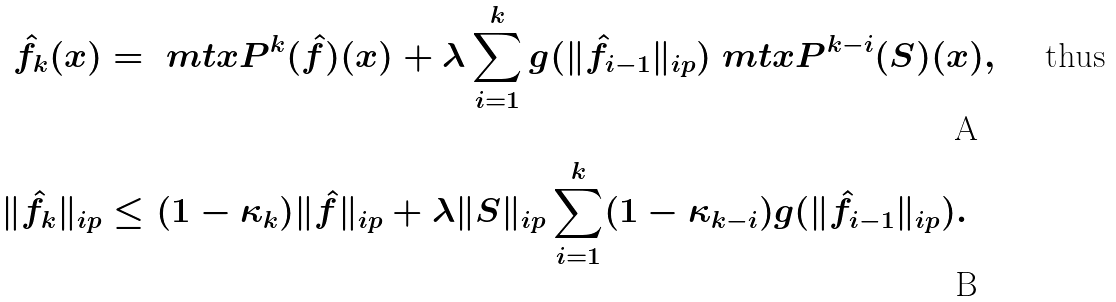Convert formula to latex. <formula><loc_0><loc_0><loc_500><loc_500>\hat { f } _ { k } ( x ) & = \ m t x { P } ^ { k } ( \hat { f } ) ( x ) + \lambda \sum _ { i = 1 } ^ { k } g ( \| \hat { f } _ { i - 1 } \| _ { \L i p } ) \ m t x { P } ^ { k - i } ( S ) ( x ) , \quad \text { thus } \\ \| \hat { f } _ { k } \| _ { \L i p } & \leq ( 1 - \kappa _ { k } ) \| \hat { f } \| _ { \L i p } + \lambda \| S \| _ { \L i p } \sum _ { i = 1 } ^ { k } ( 1 - \kappa _ { k - i } ) g ( \| \hat { f } _ { i - 1 } \| _ { \L i p } ) .</formula> 